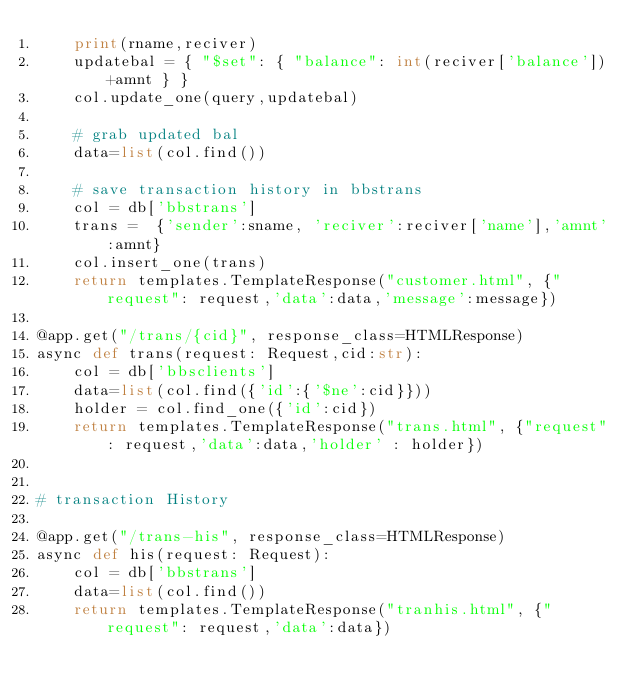Convert code to text. <code><loc_0><loc_0><loc_500><loc_500><_Python_>    print(rname,reciver)
    updatebal = { "$set": { "balance": int(reciver['balance'])+amnt } }
    col.update_one(query,updatebal)

    # grab updated bal
    data=list(col.find())

    # save transaction history in bbstrans
    col = db['bbstrans']
    trans =  {'sender':sname, 'reciver':reciver['name'],'amnt':amnt}
    col.insert_one(trans)
    return templates.TemplateResponse("customer.html", {"request": request,'data':data,'message':message})

@app.get("/trans/{cid}", response_class=HTMLResponse)
async def trans(request: Request,cid:str):
    col = db['bbsclients']
    data=list(col.find({'id':{'$ne':cid}}))
    holder = col.find_one({'id':cid})
    return templates.TemplateResponse("trans.html", {"request": request,'data':data,'holder' : holder})


# transaction History

@app.get("/trans-his", response_class=HTMLResponse)
async def his(request: Request):
    col = db['bbstrans']
    data=list(col.find())
    return templates.TemplateResponse("tranhis.html", {"request": request,'data':data})</code> 